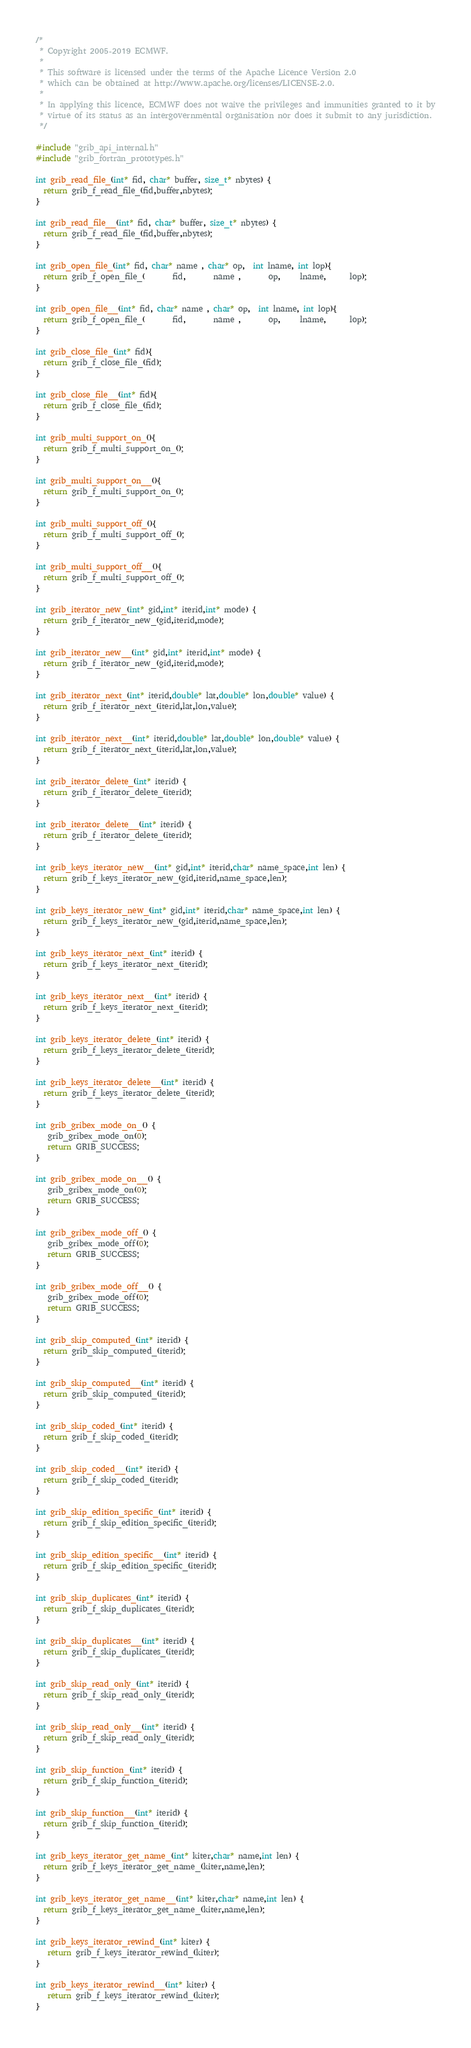<code> <loc_0><loc_0><loc_500><loc_500><_C_>/*
 * Copyright 2005-2019 ECMWF.
 *
 * This software is licensed under the terms of the Apache Licence Version 2.0
 * which can be obtained at http://www.apache.org/licenses/LICENSE-2.0.
 *
 * In applying this licence, ECMWF does not waive the privileges and immunities granted to it by
 * virtue of its status as an intergovernmental organisation nor does it submit to any jurisdiction.
 */

#include "grib_api_internal.h"
#include "grib_fortran_prototypes.h"

int grib_read_file_(int* fid, char* buffer, size_t* nbytes) {
  return grib_f_read_file_(fid,buffer,nbytes);
}

int grib_read_file__(int* fid, char* buffer, size_t* nbytes) {
  return grib_f_read_file_(fid,buffer,nbytes);
}

int grib_open_file_(int* fid, char* name , char* op,  int lname, int lop){
  return grib_f_open_file_(       fid,       name ,       op,     lname,      lop);
}

int grib_open_file__(int* fid, char* name , char* op,  int lname, int lop){
  return grib_f_open_file_(       fid,       name ,       op,     lname,      lop);
}

int grib_close_file_(int* fid){
  return grib_f_close_file_(fid);
}

int grib_close_file__(int* fid){
  return grib_f_close_file_(fid);
}

int grib_multi_support_on_(){
  return grib_f_multi_support_on_();
}

int grib_multi_support_on__(){
  return grib_f_multi_support_on_();
}

int grib_multi_support_off_(){
  return grib_f_multi_support_off_();
}

int grib_multi_support_off__(){
  return grib_f_multi_support_off_();
}

int grib_iterator_new_(int* gid,int* iterid,int* mode) {
  return grib_f_iterator_new_(gid,iterid,mode);
}

int grib_iterator_new__(int* gid,int* iterid,int* mode) {
  return grib_f_iterator_new_(gid,iterid,mode);
}

int grib_iterator_next_(int* iterid,double* lat,double* lon,double* value) {
  return grib_f_iterator_next_(iterid,lat,lon,value);
}

int grib_iterator_next__(int* iterid,double* lat,double* lon,double* value) {
  return grib_f_iterator_next_(iterid,lat,lon,value);
}

int grib_iterator_delete_(int* iterid) {
  return grib_f_iterator_delete_(iterid);
}

int grib_iterator_delete__(int* iterid) {
  return grib_f_iterator_delete_(iterid);
}

int grib_keys_iterator_new__(int* gid,int* iterid,char* name_space,int len) {
  return grib_f_keys_iterator_new_(gid,iterid,name_space,len);
}

int grib_keys_iterator_new_(int* gid,int* iterid,char* name_space,int len) {
  return grib_f_keys_iterator_new_(gid,iterid,name_space,len);
}

int grib_keys_iterator_next_(int* iterid) {
  return grib_f_keys_iterator_next_(iterid);
}

int grib_keys_iterator_next__(int* iterid) {
  return grib_f_keys_iterator_next_(iterid);
}

int grib_keys_iterator_delete_(int* iterid) {
  return grib_f_keys_iterator_delete_(iterid);
}

int grib_keys_iterator_delete__(int* iterid) {
  return grib_f_keys_iterator_delete_(iterid);
}

int grib_gribex_mode_on_() {
   grib_gribex_mode_on(0);
   return GRIB_SUCCESS;
}

int grib_gribex_mode_on__() {
   grib_gribex_mode_on(0);
   return GRIB_SUCCESS;
}

int grib_gribex_mode_off_() {
   grib_gribex_mode_off(0);
   return GRIB_SUCCESS;
}

int grib_gribex_mode_off__() {
   grib_gribex_mode_off(0);
   return GRIB_SUCCESS;
}

int grib_skip_computed_(int* iterid) {
  return grib_skip_computed_(iterid);
}

int grib_skip_computed__(int* iterid) {
  return grib_skip_computed_(iterid);
}

int grib_skip_coded_(int* iterid) {
  return grib_f_skip_coded_(iterid);
}

int grib_skip_coded__(int* iterid) {
  return grib_f_skip_coded_(iterid);
}

int grib_skip_edition_specific_(int* iterid) {
  return grib_f_skip_edition_specific_(iterid);
}

int grib_skip_edition_specific__(int* iterid) {
  return grib_f_skip_edition_specific_(iterid);
}

int grib_skip_duplicates_(int* iterid) {
  return grib_f_skip_duplicates_(iterid);
}

int grib_skip_duplicates__(int* iterid) {
  return grib_f_skip_duplicates_(iterid);
}

int grib_skip_read_only_(int* iterid) {
  return grib_f_skip_read_only_(iterid);
}

int grib_skip_read_only__(int* iterid) {
  return grib_f_skip_read_only_(iterid);
}

int grib_skip_function_(int* iterid) {
  return grib_f_skip_function_(iterid);
}

int grib_skip_function__(int* iterid) {
  return grib_f_skip_function_(iterid);
}

int grib_keys_iterator_get_name_(int* kiter,char* name,int len) {
  return grib_f_keys_iterator_get_name_(kiter,name,len);
}

int grib_keys_iterator_get_name__(int* kiter,char* name,int len) {
  return grib_f_keys_iterator_get_name_(kiter,name,len);
}

int grib_keys_iterator_rewind_(int* kiter) {
   return grib_f_keys_iterator_rewind_(kiter);
}

int grib_keys_iterator_rewind__(int* kiter) {
   return grib_f_keys_iterator_rewind_(kiter);
}
</code> 